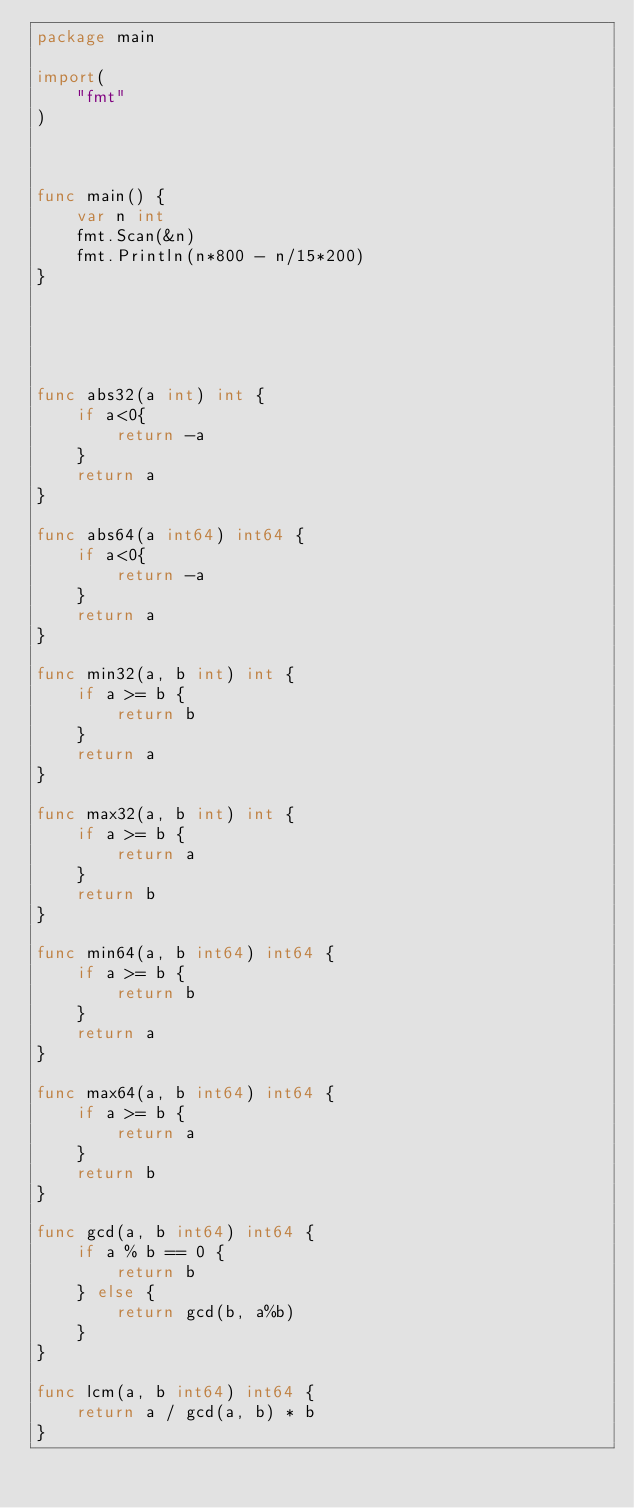Convert code to text. <code><loc_0><loc_0><loc_500><loc_500><_Go_>package main

import(
    "fmt"
)



func main() {
    var n int
    fmt.Scan(&n)
    fmt.Println(n*800 - n/15*200)
}





func abs32(a int) int {
    if a<0{
        return -a
    }
    return a
}

func abs64(a int64) int64 {
    if a<0{
        return -a
    }
    return a
}

func min32(a, b int) int {
    if a >= b {
        return b
    }
    return a
}

func max32(a, b int) int {
    if a >= b {
        return a
    }
    return b
}

func min64(a, b int64) int64 {
    if a >= b {
        return b
    }
    return a
}

func max64(a, b int64) int64 {
    if a >= b {
        return a
    }
    return b
}

func gcd(a, b int64) int64 {
    if a % b == 0 {
        return b
    } else {
        return gcd(b, a%b)
    }
}

func lcm(a, b int64) int64 {
    return a / gcd(a, b) * b
}
</code> 